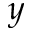Convert formula to latex. <formula><loc_0><loc_0><loc_500><loc_500>y</formula> 